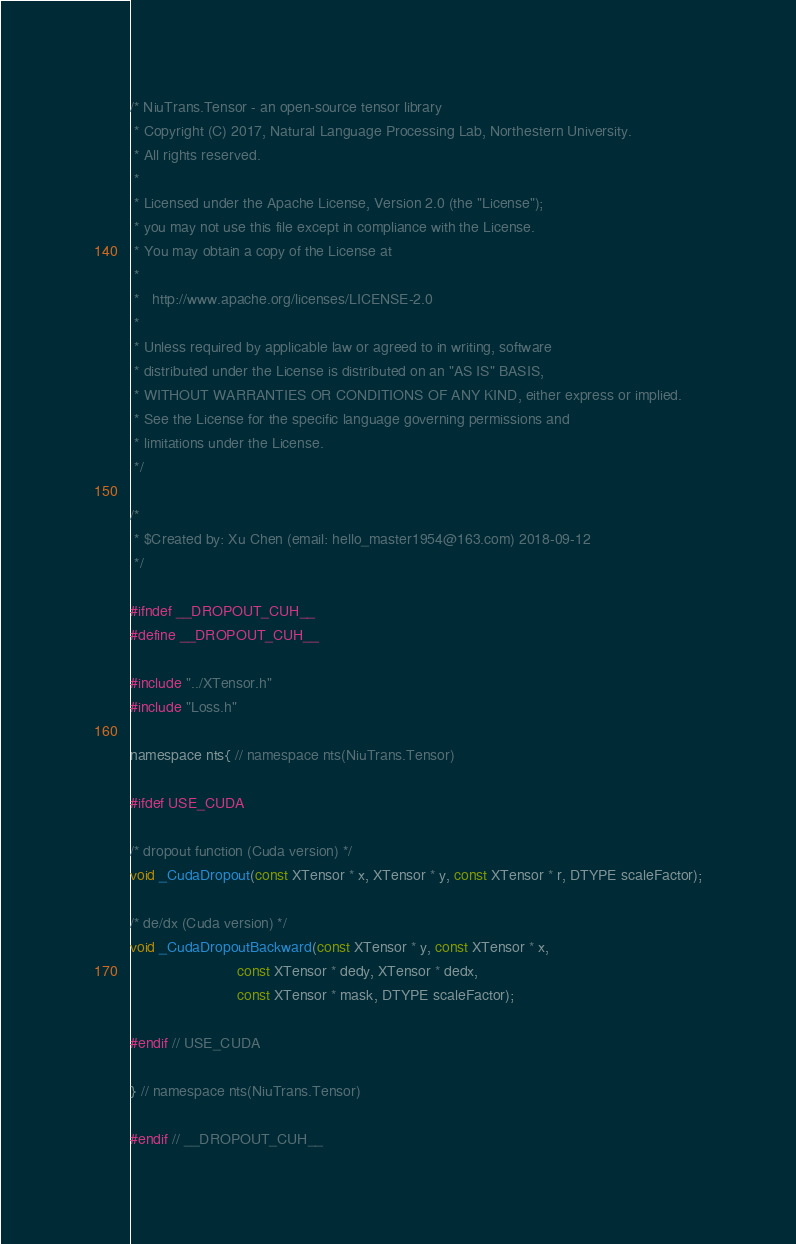<code> <loc_0><loc_0><loc_500><loc_500><_Cuda_>/* NiuTrans.Tensor - an open-source tensor library
 * Copyright (C) 2017, Natural Language Processing Lab, Northestern University. 
 * All rights reserved.
 *
 * Licensed under the Apache License, Version 2.0 (the "License");
 * you may not use this file except in compliance with the License.
 * You may obtain a copy of the License at
 *
 *   http://www.apache.org/licenses/LICENSE-2.0
 *
 * Unless required by applicable law or agreed to in writing, software
 * distributed under the License is distributed on an "AS IS" BASIS,
 * WITHOUT WARRANTIES OR CONDITIONS OF ANY KIND, either express or implied.
 * See the License for the specific language governing permissions and
 * limitations under the License.
 */

/*
 * $Created by: Xu Chen (email: hello_master1954@163.com) 2018-09-12
 */

#ifndef __DROPOUT_CUH__
#define __DROPOUT_CUH__

#include "../XTensor.h"
#include "Loss.h"

namespace nts{ // namespace nts(NiuTrans.Tensor)

#ifdef USE_CUDA

/* dropout function (Cuda version) */
void _CudaDropout(const XTensor * x, XTensor * y, const XTensor * r, DTYPE scaleFactor);

/* de/dx (Cuda version) */
void _CudaDropoutBackward(const XTensor * y, const XTensor * x,
                          const XTensor * dedy, XTensor * dedx,
                          const XTensor * mask, DTYPE scaleFactor);

#endif // USE_CUDA

} // namespace nts(NiuTrans.Tensor)

#endif // __DROPOUT_CUH__</code> 